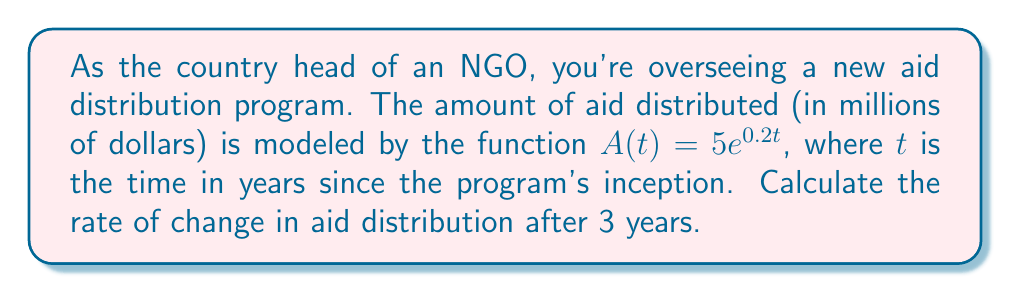Provide a solution to this math problem. To solve this problem, we need to follow these steps:

1) The given function for aid distribution is:
   $A(t) = 5e^{0.2t}$

2) To find the rate of change, we need to differentiate this function with respect to t:
   $$\frac{dA}{dt} = 5 \cdot 0.2e^{0.2t} = e^{0.2t}$$

3) This derivative represents the instantaneous rate of change of aid distribution at any time t.

4) To find the rate of change after 3 years, we substitute t = 3 into this derivative:
   $$\frac{dA}{dt}\bigg|_{t=3} = e^{0.2(3)} = e^{0.6}$$

5) Calculate this value:
   $e^{0.6} \approx 1.8221$ (rounded to 4 decimal places)

Therefore, after 3 years, the rate of change in aid distribution is approximately 1.8221 million dollars per year.
Answer: $1.8221$ million dollars per year 